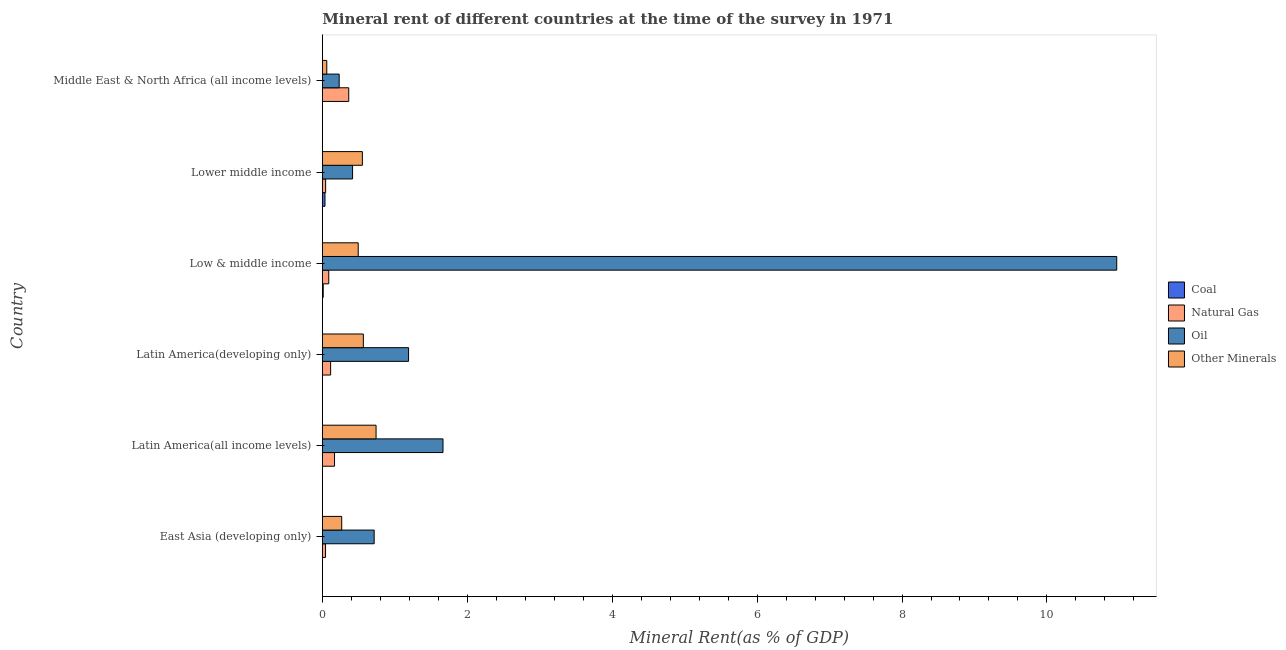How many different coloured bars are there?
Offer a very short reply. 4. How many groups of bars are there?
Provide a short and direct response. 6. Are the number of bars on each tick of the Y-axis equal?
Your answer should be very brief. Yes. How many bars are there on the 3rd tick from the top?
Your answer should be very brief. 4. What is the label of the 4th group of bars from the top?
Ensure brevity in your answer.  Latin America(developing only). What is the  rent of other minerals in Middle East & North Africa (all income levels)?
Your answer should be very brief. 0.06. Across all countries, what is the maximum coal rent?
Offer a terse response. 0.04. Across all countries, what is the minimum coal rent?
Your response must be concise. 2.424677920522231e-5. In which country was the coal rent maximum?
Keep it short and to the point. Lower middle income. In which country was the  rent of other minerals minimum?
Make the answer very short. Middle East & North Africa (all income levels). What is the total natural gas rent in the graph?
Make the answer very short. 0.83. What is the difference between the coal rent in Latin America(developing only) and that in Middle East & North Africa (all income levels)?
Provide a succinct answer. -0. What is the difference between the  rent of other minerals in Latin America(developing only) and the natural gas rent in Middle East & North Africa (all income levels)?
Your answer should be compact. 0.2. What is the average  rent of other minerals per country?
Keep it short and to the point. 0.45. What is the difference between the  rent of other minerals and coal rent in East Asia (developing only)?
Your response must be concise. 0.27. What is the ratio of the oil rent in Latin America(all income levels) to that in Middle East & North Africa (all income levels)?
Provide a succinct answer. 7.16. Is the difference between the oil rent in Latin America(all income levels) and Latin America(developing only) greater than the difference between the natural gas rent in Latin America(all income levels) and Latin America(developing only)?
Offer a very short reply. Yes. What is the difference between the highest and the second highest  rent of other minerals?
Keep it short and to the point. 0.17. What is the difference between the highest and the lowest natural gas rent?
Provide a short and direct response. 0.32. In how many countries, is the  rent of other minerals greater than the average  rent of other minerals taken over all countries?
Your response must be concise. 4. Is the sum of the  rent of other minerals in Latin America(developing only) and Middle East & North Africa (all income levels) greater than the maximum natural gas rent across all countries?
Your answer should be compact. Yes. What does the 1st bar from the top in Latin America(all income levels) represents?
Offer a terse response. Other Minerals. What does the 1st bar from the bottom in Latin America(developing only) represents?
Your response must be concise. Coal. How many bars are there?
Ensure brevity in your answer.  24. Are all the bars in the graph horizontal?
Your answer should be compact. Yes. How many countries are there in the graph?
Offer a very short reply. 6. What is the difference between two consecutive major ticks on the X-axis?
Provide a succinct answer. 2. How many legend labels are there?
Your response must be concise. 4. How are the legend labels stacked?
Your answer should be compact. Vertical. What is the title of the graph?
Provide a succinct answer. Mineral rent of different countries at the time of the survey in 1971. Does "Public sector management" appear as one of the legend labels in the graph?
Give a very brief answer. No. What is the label or title of the X-axis?
Make the answer very short. Mineral Rent(as % of GDP). What is the Mineral Rent(as % of GDP) of Coal in East Asia (developing only)?
Your answer should be compact. 0. What is the Mineral Rent(as % of GDP) in Natural Gas in East Asia (developing only)?
Your answer should be very brief. 0.04. What is the Mineral Rent(as % of GDP) in Oil in East Asia (developing only)?
Keep it short and to the point. 0.72. What is the Mineral Rent(as % of GDP) of Other Minerals in East Asia (developing only)?
Your answer should be very brief. 0.27. What is the Mineral Rent(as % of GDP) of Coal in Latin America(all income levels)?
Keep it short and to the point. 2.424677920522231e-5. What is the Mineral Rent(as % of GDP) of Natural Gas in Latin America(all income levels)?
Provide a succinct answer. 0.17. What is the Mineral Rent(as % of GDP) in Oil in Latin America(all income levels)?
Your response must be concise. 1.67. What is the Mineral Rent(as % of GDP) of Other Minerals in Latin America(all income levels)?
Your response must be concise. 0.74. What is the Mineral Rent(as % of GDP) in Coal in Latin America(developing only)?
Provide a succinct answer. 3.74111743887933e-5. What is the Mineral Rent(as % of GDP) of Natural Gas in Latin America(developing only)?
Make the answer very short. 0.11. What is the Mineral Rent(as % of GDP) of Oil in Latin America(developing only)?
Provide a short and direct response. 1.19. What is the Mineral Rent(as % of GDP) in Other Minerals in Latin America(developing only)?
Make the answer very short. 0.57. What is the Mineral Rent(as % of GDP) in Coal in Low & middle income?
Keep it short and to the point. 0.01. What is the Mineral Rent(as % of GDP) of Natural Gas in Low & middle income?
Keep it short and to the point. 0.09. What is the Mineral Rent(as % of GDP) in Oil in Low & middle income?
Provide a short and direct response. 10.96. What is the Mineral Rent(as % of GDP) in Other Minerals in Low & middle income?
Make the answer very short. 0.5. What is the Mineral Rent(as % of GDP) in Coal in Lower middle income?
Provide a succinct answer. 0.04. What is the Mineral Rent(as % of GDP) in Natural Gas in Lower middle income?
Your answer should be compact. 0.05. What is the Mineral Rent(as % of GDP) in Oil in Lower middle income?
Offer a terse response. 0.42. What is the Mineral Rent(as % of GDP) of Other Minerals in Lower middle income?
Make the answer very short. 0.55. What is the Mineral Rent(as % of GDP) in Coal in Middle East & North Africa (all income levels)?
Offer a very short reply. 0. What is the Mineral Rent(as % of GDP) of Natural Gas in Middle East & North Africa (all income levels)?
Provide a succinct answer. 0.36. What is the Mineral Rent(as % of GDP) in Oil in Middle East & North Africa (all income levels)?
Make the answer very short. 0.23. What is the Mineral Rent(as % of GDP) of Other Minerals in Middle East & North Africa (all income levels)?
Your answer should be very brief. 0.06. Across all countries, what is the maximum Mineral Rent(as % of GDP) in Coal?
Make the answer very short. 0.04. Across all countries, what is the maximum Mineral Rent(as % of GDP) in Natural Gas?
Your response must be concise. 0.36. Across all countries, what is the maximum Mineral Rent(as % of GDP) in Oil?
Provide a short and direct response. 10.96. Across all countries, what is the maximum Mineral Rent(as % of GDP) of Other Minerals?
Offer a very short reply. 0.74. Across all countries, what is the minimum Mineral Rent(as % of GDP) of Coal?
Ensure brevity in your answer.  2.424677920522231e-5. Across all countries, what is the minimum Mineral Rent(as % of GDP) of Natural Gas?
Make the answer very short. 0.04. Across all countries, what is the minimum Mineral Rent(as % of GDP) in Oil?
Your answer should be very brief. 0.23. Across all countries, what is the minimum Mineral Rent(as % of GDP) in Other Minerals?
Ensure brevity in your answer.  0.06. What is the total Mineral Rent(as % of GDP) in Coal in the graph?
Your answer should be very brief. 0.05. What is the total Mineral Rent(as % of GDP) of Natural Gas in the graph?
Make the answer very short. 0.83. What is the total Mineral Rent(as % of GDP) in Oil in the graph?
Ensure brevity in your answer.  15.18. What is the total Mineral Rent(as % of GDP) of Other Minerals in the graph?
Provide a succinct answer. 2.68. What is the difference between the Mineral Rent(as % of GDP) of Natural Gas in East Asia (developing only) and that in Latin America(all income levels)?
Offer a very short reply. -0.12. What is the difference between the Mineral Rent(as % of GDP) of Oil in East Asia (developing only) and that in Latin America(all income levels)?
Offer a terse response. -0.95. What is the difference between the Mineral Rent(as % of GDP) in Other Minerals in East Asia (developing only) and that in Latin America(all income levels)?
Your answer should be compact. -0.47. What is the difference between the Mineral Rent(as % of GDP) of Natural Gas in East Asia (developing only) and that in Latin America(developing only)?
Your answer should be very brief. -0.07. What is the difference between the Mineral Rent(as % of GDP) of Oil in East Asia (developing only) and that in Latin America(developing only)?
Make the answer very short. -0.47. What is the difference between the Mineral Rent(as % of GDP) of Other Minerals in East Asia (developing only) and that in Latin America(developing only)?
Make the answer very short. -0.3. What is the difference between the Mineral Rent(as % of GDP) of Coal in East Asia (developing only) and that in Low & middle income?
Your response must be concise. -0.01. What is the difference between the Mineral Rent(as % of GDP) of Natural Gas in East Asia (developing only) and that in Low & middle income?
Provide a short and direct response. -0.04. What is the difference between the Mineral Rent(as % of GDP) in Oil in East Asia (developing only) and that in Low & middle income?
Keep it short and to the point. -10.25. What is the difference between the Mineral Rent(as % of GDP) in Other Minerals in East Asia (developing only) and that in Low & middle income?
Offer a terse response. -0.23. What is the difference between the Mineral Rent(as % of GDP) of Coal in East Asia (developing only) and that in Lower middle income?
Your answer should be very brief. -0.04. What is the difference between the Mineral Rent(as % of GDP) of Natural Gas in East Asia (developing only) and that in Lower middle income?
Your response must be concise. -0. What is the difference between the Mineral Rent(as % of GDP) in Oil in East Asia (developing only) and that in Lower middle income?
Offer a terse response. 0.3. What is the difference between the Mineral Rent(as % of GDP) of Other Minerals in East Asia (developing only) and that in Lower middle income?
Your response must be concise. -0.28. What is the difference between the Mineral Rent(as % of GDP) of Coal in East Asia (developing only) and that in Middle East & North Africa (all income levels)?
Give a very brief answer. -0. What is the difference between the Mineral Rent(as % of GDP) in Natural Gas in East Asia (developing only) and that in Middle East & North Africa (all income levels)?
Provide a short and direct response. -0.32. What is the difference between the Mineral Rent(as % of GDP) of Oil in East Asia (developing only) and that in Middle East & North Africa (all income levels)?
Offer a very short reply. 0.48. What is the difference between the Mineral Rent(as % of GDP) of Other Minerals in East Asia (developing only) and that in Middle East & North Africa (all income levels)?
Ensure brevity in your answer.  0.21. What is the difference between the Mineral Rent(as % of GDP) of Coal in Latin America(all income levels) and that in Latin America(developing only)?
Keep it short and to the point. -0. What is the difference between the Mineral Rent(as % of GDP) in Natural Gas in Latin America(all income levels) and that in Latin America(developing only)?
Ensure brevity in your answer.  0.05. What is the difference between the Mineral Rent(as % of GDP) of Oil in Latin America(all income levels) and that in Latin America(developing only)?
Ensure brevity in your answer.  0.48. What is the difference between the Mineral Rent(as % of GDP) in Other Minerals in Latin America(all income levels) and that in Latin America(developing only)?
Provide a succinct answer. 0.18. What is the difference between the Mineral Rent(as % of GDP) in Coal in Latin America(all income levels) and that in Low & middle income?
Offer a very short reply. -0.01. What is the difference between the Mineral Rent(as % of GDP) in Oil in Latin America(all income levels) and that in Low & middle income?
Offer a very short reply. -9.3. What is the difference between the Mineral Rent(as % of GDP) in Other Minerals in Latin America(all income levels) and that in Low & middle income?
Ensure brevity in your answer.  0.25. What is the difference between the Mineral Rent(as % of GDP) in Coal in Latin America(all income levels) and that in Lower middle income?
Provide a short and direct response. -0.04. What is the difference between the Mineral Rent(as % of GDP) of Natural Gas in Latin America(all income levels) and that in Lower middle income?
Keep it short and to the point. 0.12. What is the difference between the Mineral Rent(as % of GDP) in Oil in Latin America(all income levels) and that in Lower middle income?
Your answer should be very brief. 1.25. What is the difference between the Mineral Rent(as % of GDP) in Other Minerals in Latin America(all income levels) and that in Lower middle income?
Give a very brief answer. 0.19. What is the difference between the Mineral Rent(as % of GDP) in Coal in Latin America(all income levels) and that in Middle East & North Africa (all income levels)?
Offer a terse response. -0. What is the difference between the Mineral Rent(as % of GDP) in Natural Gas in Latin America(all income levels) and that in Middle East & North Africa (all income levels)?
Offer a very short reply. -0.2. What is the difference between the Mineral Rent(as % of GDP) in Oil in Latin America(all income levels) and that in Middle East & North Africa (all income levels)?
Ensure brevity in your answer.  1.43. What is the difference between the Mineral Rent(as % of GDP) of Other Minerals in Latin America(all income levels) and that in Middle East & North Africa (all income levels)?
Provide a short and direct response. 0.68. What is the difference between the Mineral Rent(as % of GDP) of Coal in Latin America(developing only) and that in Low & middle income?
Your response must be concise. -0.01. What is the difference between the Mineral Rent(as % of GDP) of Natural Gas in Latin America(developing only) and that in Low & middle income?
Provide a short and direct response. 0.03. What is the difference between the Mineral Rent(as % of GDP) of Oil in Latin America(developing only) and that in Low & middle income?
Ensure brevity in your answer.  -9.77. What is the difference between the Mineral Rent(as % of GDP) of Other Minerals in Latin America(developing only) and that in Low & middle income?
Offer a terse response. 0.07. What is the difference between the Mineral Rent(as % of GDP) in Coal in Latin America(developing only) and that in Lower middle income?
Offer a very short reply. -0.04. What is the difference between the Mineral Rent(as % of GDP) of Natural Gas in Latin America(developing only) and that in Lower middle income?
Make the answer very short. 0.07. What is the difference between the Mineral Rent(as % of GDP) in Oil in Latin America(developing only) and that in Lower middle income?
Your answer should be compact. 0.77. What is the difference between the Mineral Rent(as % of GDP) of Other Minerals in Latin America(developing only) and that in Lower middle income?
Offer a terse response. 0.01. What is the difference between the Mineral Rent(as % of GDP) in Coal in Latin America(developing only) and that in Middle East & North Africa (all income levels)?
Your answer should be compact. -0. What is the difference between the Mineral Rent(as % of GDP) in Natural Gas in Latin America(developing only) and that in Middle East & North Africa (all income levels)?
Your answer should be very brief. -0.25. What is the difference between the Mineral Rent(as % of GDP) in Oil in Latin America(developing only) and that in Middle East & North Africa (all income levels)?
Your response must be concise. 0.96. What is the difference between the Mineral Rent(as % of GDP) in Other Minerals in Latin America(developing only) and that in Middle East & North Africa (all income levels)?
Offer a very short reply. 0.5. What is the difference between the Mineral Rent(as % of GDP) in Coal in Low & middle income and that in Lower middle income?
Your response must be concise. -0.02. What is the difference between the Mineral Rent(as % of GDP) of Natural Gas in Low & middle income and that in Lower middle income?
Make the answer very short. 0.04. What is the difference between the Mineral Rent(as % of GDP) of Oil in Low & middle income and that in Lower middle income?
Your answer should be compact. 10.55. What is the difference between the Mineral Rent(as % of GDP) of Other Minerals in Low & middle income and that in Lower middle income?
Ensure brevity in your answer.  -0.06. What is the difference between the Mineral Rent(as % of GDP) of Coal in Low & middle income and that in Middle East & North Africa (all income levels)?
Offer a terse response. 0.01. What is the difference between the Mineral Rent(as % of GDP) in Natural Gas in Low & middle income and that in Middle East & North Africa (all income levels)?
Make the answer very short. -0.28. What is the difference between the Mineral Rent(as % of GDP) of Oil in Low & middle income and that in Middle East & North Africa (all income levels)?
Make the answer very short. 10.73. What is the difference between the Mineral Rent(as % of GDP) of Other Minerals in Low & middle income and that in Middle East & North Africa (all income levels)?
Make the answer very short. 0.43. What is the difference between the Mineral Rent(as % of GDP) in Coal in Lower middle income and that in Middle East & North Africa (all income levels)?
Your answer should be very brief. 0.04. What is the difference between the Mineral Rent(as % of GDP) of Natural Gas in Lower middle income and that in Middle East & North Africa (all income levels)?
Make the answer very short. -0.32. What is the difference between the Mineral Rent(as % of GDP) in Oil in Lower middle income and that in Middle East & North Africa (all income levels)?
Keep it short and to the point. 0.18. What is the difference between the Mineral Rent(as % of GDP) of Other Minerals in Lower middle income and that in Middle East & North Africa (all income levels)?
Your answer should be compact. 0.49. What is the difference between the Mineral Rent(as % of GDP) in Coal in East Asia (developing only) and the Mineral Rent(as % of GDP) in Natural Gas in Latin America(all income levels)?
Your answer should be very brief. -0.17. What is the difference between the Mineral Rent(as % of GDP) of Coal in East Asia (developing only) and the Mineral Rent(as % of GDP) of Oil in Latin America(all income levels)?
Keep it short and to the point. -1.67. What is the difference between the Mineral Rent(as % of GDP) of Coal in East Asia (developing only) and the Mineral Rent(as % of GDP) of Other Minerals in Latin America(all income levels)?
Give a very brief answer. -0.74. What is the difference between the Mineral Rent(as % of GDP) of Natural Gas in East Asia (developing only) and the Mineral Rent(as % of GDP) of Oil in Latin America(all income levels)?
Your answer should be compact. -1.62. What is the difference between the Mineral Rent(as % of GDP) of Natural Gas in East Asia (developing only) and the Mineral Rent(as % of GDP) of Other Minerals in Latin America(all income levels)?
Make the answer very short. -0.7. What is the difference between the Mineral Rent(as % of GDP) of Oil in East Asia (developing only) and the Mineral Rent(as % of GDP) of Other Minerals in Latin America(all income levels)?
Your answer should be very brief. -0.03. What is the difference between the Mineral Rent(as % of GDP) in Coal in East Asia (developing only) and the Mineral Rent(as % of GDP) in Natural Gas in Latin America(developing only)?
Your response must be concise. -0.11. What is the difference between the Mineral Rent(as % of GDP) of Coal in East Asia (developing only) and the Mineral Rent(as % of GDP) of Oil in Latin America(developing only)?
Provide a short and direct response. -1.19. What is the difference between the Mineral Rent(as % of GDP) of Coal in East Asia (developing only) and the Mineral Rent(as % of GDP) of Other Minerals in Latin America(developing only)?
Keep it short and to the point. -0.57. What is the difference between the Mineral Rent(as % of GDP) of Natural Gas in East Asia (developing only) and the Mineral Rent(as % of GDP) of Oil in Latin America(developing only)?
Your answer should be very brief. -1.15. What is the difference between the Mineral Rent(as % of GDP) of Natural Gas in East Asia (developing only) and the Mineral Rent(as % of GDP) of Other Minerals in Latin America(developing only)?
Offer a very short reply. -0.52. What is the difference between the Mineral Rent(as % of GDP) in Oil in East Asia (developing only) and the Mineral Rent(as % of GDP) in Other Minerals in Latin America(developing only)?
Provide a short and direct response. 0.15. What is the difference between the Mineral Rent(as % of GDP) of Coal in East Asia (developing only) and the Mineral Rent(as % of GDP) of Natural Gas in Low & middle income?
Provide a succinct answer. -0.09. What is the difference between the Mineral Rent(as % of GDP) in Coal in East Asia (developing only) and the Mineral Rent(as % of GDP) in Oil in Low & middle income?
Ensure brevity in your answer.  -10.96. What is the difference between the Mineral Rent(as % of GDP) of Coal in East Asia (developing only) and the Mineral Rent(as % of GDP) of Other Minerals in Low & middle income?
Your answer should be compact. -0.5. What is the difference between the Mineral Rent(as % of GDP) in Natural Gas in East Asia (developing only) and the Mineral Rent(as % of GDP) in Oil in Low & middle income?
Make the answer very short. -10.92. What is the difference between the Mineral Rent(as % of GDP) in Natural Gas in East Asia (developing only) and the Mineral Rent(as % of GDP) in Other Minerals in Low & middle income?
Keep it short and to the point. -0.45. What is the difference between the Mineral Rent(as % of GDP) in Oil in East Asia (developing only) and the Mineral Rent(as % of GDP) in Other Minerals in Low & middle income?
Offer a very short reply. 0.22. What is the difference between the Mineral Rent(as % of GDP) of Coal in East Asia (developing only) and the Mineral Rent(as % of GDP) of Natural Gas in Lower middle income?
Your answer should be very brief. -0.05. What is the difference between the Mineral Rent(as % of GDP) in Coal in East Asia (developing only) and the Mineral Rent(as % of GDP) in Oil in Lower middle income?
Give a very brief answer. -0.42. What is the difference between the Mineral Rent(as % of GDP) of Coal in East Asia (developing only) and the Mineral Rent(as % of GDP) of Other Minerals in Lower middle income?
Your response must be concise. -0.55. What is the difference between the Mineral Rent(as % of GDP) in Natural Gas in East Asia (developing only) and the Mineral Rent(as % of GDP) in Oil in Lower middle income?
Offer a very short reply. -0.37. What is the difference between the Mineral Rent(as % of GDP) in Natural Gas in East Asia (developing only) and the Mineral Rent(as % of GDP) in Other Minerals in Lower middle income?
Ensure brevity in your answer.  -0.51. What is the difference between the Mineral Rent(as % of GDP) in Oil in East Asia (developing only) and the Mineral Rent(as % of GDP) in Other Minerals in Lower middle income?
Offer a terse response. 0.16. What is the difference between the Mineral Rent(as % of GDP) in Coal in East Asia (developing only) and the Mineral Rent(as % of GDP) in Natural Gas in Middle East & North Africa (all income levels)?
Your answer should be very brief. -0.36. What is the difference between the Mineral Rent(as % of GDP) of Coal in East Asia (developing only) and the Mineral Rent(as % of GDP) of Oil in Middle East & North Africa (all income levels)?
Provide a short and direct response. -0.23. What is the difference between the Mineral Rent(as % of GDP) in Coal in East Asia (developing only) and the Mineral Rent(as % of GDP) in Other Minerals in Middle East & North Africa (all income levels)?
Ensure brevity in your answer.  -0.06. What is the difference between the Mineral Rent(as % of GDP) of Natural Gas in East Asia (developing only) and the Mineral Rent(as % of GDP) of Oil in Middle East & North Africa (all income levels)?
Offer a very short reply. -0.19. What is the difference between the Mineral Rent(as % of GDP) in Natural Gas in East Asia (developing only) and the Mineral Rent(as % of GDP) in Other Minerals in Middle East & North Africa (all income levels)?
Make the answer very short. -0.02. What is the difference between the Mineral Rent(as % of GDP) in Oil in East Asia (developing only) and the Mineral Rent(as % of GDP) in Other Minerals in Middle East & North Africa (all income levels)?
Make the answer very short. 0.65. What is the difference between the Mineral Rent(as % of GDP) in Coal in Latin America(all income levels) and the Mineral Rent(as % of GDP) in Natural Gas in Latin America(developing only)?
Your response must be concise. -0.11. What is the difference between the Mineral Rent(as % of GDP) of Coal in Latin America(all income levels) and the Mineral Rent(as % of GDP) of Oil in Latin America(developing only)?
Your response must be concise. -1.19. What is the difference between the Mineral Rent(as % of GDP) of Coal in Latin America(all income levels) and the Mineral Rent(as % of GDP) of Other Minerals in Latin America(developing only)?
Provide a succinct answer. -0.57. What is the difference between the Mineral Rent(as % of GDP) in Natural Gas in Latin America(all income levels) and the Mineral Rent(as % of GDP) in Oil in Latin America(developing only)?
Offer a terse response. -1.02. What is the difference between the Mineral Rent(as % of GDP) of Natural Gas in Latin America(all income levels) and the Mineral Rent(as % of GDP) of Other Minerals in Latin America(developing only)?
Give a very brief answer. -0.4. What is the difference between the Mineral Rent(as % of GDP) of Oil in Latin America(all income levels) and the Mineral Rent(as % of GDP) of Other Minerals in Latin America(developing only)?
Provide a succinct answer. 1.1. What is the difference between the Mineral Rent(as % of GDP) in Coal in Latin America(all income levels) and the Mineral Rent(as % of GDP) in Natural Gas in Low & middle income?
Keep it short and to the point. -0.09. What is the difference between the Mineral Rent(as % of GDP) in Coal in Latin America(all income levels) and the Mineral Rent(as % of GDP) in Oil in Low & middle income?
Keep it short and to the point. -10.96. What is the difference between the Mineral Rent(as % of GDP) in Coal in Latin America(all income levels) and the Mineral Rent(as % of GDP) in Other Minerals in Low & middle income?
Provide a succinct answer. -0.5. What is the difference between the Mineral Rent(as % of GDP) in Natural Gas in Latin America(all income levels) and the Mineral Rent(as % of GDP) in Oil in Low & middle income?
Your answer should be very brief. -10.79. What is the difference between the Mineral Rent(as % of GDP) in Natural Gas in Latin America(all income levels) and the Mineral Rent(as % of GDP) in Other Minerals in Low & middle income?
Your response must be concise. -0.33. What is the difference between the Mineral Rent(as % of GDP) of Oil in Latin America(all income levels) and the Mineral Rent(as % of GDP) of Other Minerals in Low & middle income?
Provide a short and direct response. 1.17. What is the difference between the Mineral Rent(as % of GDP) in Coal in Latin America(all income levels) and the Mineral Rent(as % of GDP) in Natural Gas in Lower middle income?
Offer a very short reply. -0.05. What is the difference between the Mineral Rent(as % of GDP) in Coal in Latin America(all income levels) and the Mineral Rent(as % of GDP) in Oil in Lower middle income?
Provide a short and direct response. -0.42. What is the difference between the Mineral Rent(as % of GDP) of Coal in Latin America(all income levels) and the Mineral Rent(as % of GDP) of Other Minerals in Lower middle income?
Your answer should be compact. -0.55. What is the difference between the Mineral Rent(as % of GDP) in Natural Gas in Latin America(all income levels) and the Mineral Rent(as % of GDP) in Oil in Lower middle income?
Offer a terse response. -0.25. What is the difference between the Mineral Rent(as % of GDP) in Natural Gas in Latin America(all income levels) and the Mineral Rent(as % of GDP) in Other Minerals in Lower middle income?
Give a very brief answer. -0.38. What is the difference between the Mineral Rent(as % of GDP) in Oil in Latin America(all income levels) and the Mineral Rent(as % of GDP) in Other Minerals in Lower middle income?
Offer a terse response. 1.11. What is the difference between the Mineral Rent(as % of GDP) in Coal in Latin America(all income levels) and the Mineral Rent(as % of GDP) in Natural Gas in Middle East & North Africa (all income levels)?
Make the answer very short. -0.36. What is the difference between the Mineral Rent(as % of GDP) of Coal in Latin America(all income levels) and the Mineral Rent(as % of GDP) of Oil in Middle East & North Africa (all income levels)?
Your response must be concise. -0.23. What is the difference between the Mineral Rent(as % of GDP) of Coal in Latin America(all income levels) and the Mineral Rent(as % of GDP) of Other Minerals in Middle East & North Africa (all income levels)?
Your response must be concise. -0.06. What is the difference between the Mineral Rent(as % of GDP) of Natural Gas in Latin America(all income levels) and the Mineral Rent(as % of GDP) of Oil in Middle East & North Africa (all income levels)?
Keep it short and to the point. -0.06. What is the difference between the Mineral Rent(as % of GDP) in Natural Gas in Latin America(all income levels) and the Mineral Rent(as % of GDP) in Other Minerals in Middle East & North Africa (all income levels)?
Offer a terse response. 0.11. What is the difference between the Mineral Rent(as % of GDP) of Oil in Latin America(all income levels) and the Mineral Rent(as % of GDP) of Other Minerals in Middle East & North Africa (all income levels)?
Provide a short and direct response. 1.6. What is the difference between the Mineral Rent(as % of GDP) of Coal in Latin America(developing only) and the Mineral Rent(as % of GDP) of Natural Gas in Low & middle income?
Ensure brevity in your answer.  -0.09. What is the difference between the Mineral Rent(as % of GDP) in Coal in Latin America(developing only) and the Mineral Rent(as % of GDP) in Oil in Low & middle income?
Keep it short and to the point. -10.96. What is the difference between the Mineral Rent(as % of GDP) of Coal in Latin America(developing only) and the Mineral Rent(as % of GDP) of Other Minerals in Low & middle income?
Ensure brevity in your answer.  -0.5. What is the difference between the Mineral Rent(as % of GDP) in Natural Gas in Latin America(developing only) and the Mineral Rent(as % of GDP) in Oil in Low & middle income?
Keep it short and to the point. -10.85. What is the difference between the Mineral Rent(as % of GDP) of Natural Gas in Latin America(developing only) and the Mineral Rent(as % of GDP) of Other Minerals in Low & middle income?
Ensure brevity in your answer.  -0.38. What is the difference between the Mineral Rent(as % of GDP) of Oil in Latin America(developing only) and the Mineral Rent(as % of GDP) of Other Minerals in Low & middle income?
Your answer should be compact. 0.69. What is the difference between the Mineral Rent(as % of GDP) of Coal in Latin America(developing only) and the Mineral Rent(as % of GDP) of Natural Gas in Lower middle income?
Make the answer very short. -0.05. What is the difference between the Mineral Rent(as % of GDP) in Coal in Latin America(developing only) and the Mineral Rent(as % of GDP) in Oil in Lower middle income?
Offer a very short reply. -0.42. What is the difference between the Mineral Rent(as % of GDP) in Coal in Latin America(developing only) and the Mineral Rent(as % of GDP) in Other Minerals in Lower middle income?
Provide a short and direct response. -0.55. What is the difference between the Mineral Rent(as % of GDP) of Natural Gas in Latin America(developing only) and the Mineral Rent(as % of GDP) of Oil in Lower middle income?
Your answer should be very brief. -0.3. What is the difference between the Mineral Rent(as % of GDP) in Natural Gas in Latin America(developing only) and the Mineral Rent(as % of GDP) in Other Minerals in Lower middle income?
Give a very brief answer. -0.44. What is the difference between the Mineral Rent(as % of GDP) of Oil in Latin America(developing only) and the Mineral Rent(as % of GDP) of Other Minerals in Lower middle income?
Give a very brief answer. 0.64. What is the difference between the Mineral Rent(as % of GDP) in Coal in Latin America(developing only) and the Mineral Rent(as % of GDP) in Natural Gas in Middle East & North Africa (all income levels)?
Make the answer very short. -0.36. What is the difference between the Mineral Rent(as % of GDP) of Coal in Latin America(developing only) and the Mineral Rent(as % of GDP) of Oil in Middle East & North Africa (all income levels)?
Offer a terse response. -0.23. What is the difference between the Mineral Rent(as % of GDP) in Coal in Latin America(developing only) and the Mineral Rent(as % of GDP) in Other Minerals in Middle East & North Africa (all income levels)?
Offer a terse response. -0.06. What is the difference between the Mineral Rent(as % of GDP) in Natural Gas in Latin America(developing only) and the Mineral Rent(as % of GDP) in Oil in Middle East & North Africa (all income levels)?
Ensure brevity in your answer.  -0.12. What is the difference between the Mineral Rent(as % of GDP) of Natural Gas in Latin America(developing only) and the Mineral Rent(as % of GDP) of Other Minerals in Middle East & North Africa (all income levels)?
Give a very brief answer. 0.05. What is the difference between the Mineral Rent(as % of GDP) in Oil in Latin America(developing only) and the Mineral Rent(as % of GDP) in Other Minerals in Middle East & North Africa (all income levels)?
Offer a very short reply. 1.13. What is the difference between the Mineral Rent(as % of GDP) of Coal in Low & middle income and the Mineral Rent(as % of GDP) of Natural Gas in Lower middle income?
Your response must be concise. -0.03. What is the difference between the Mineral Rent(as % of GDP) in Coal in Low & middle income and the Mineral Rent(as % of GDP) in Oil in Lower middle income?
Provide a short and direct response. -0.41. What is the difference between the Mineral Rent(as % of GDP) in Coal in Low & middle income and the Mineral Rent(as % of GDP) in Other Minerals in Lower middle income?
Your answer should be compact. -0.54. What is the difference between the Mineral Rent(as % of GDP) in Natural Gas in Low & middle income and the Mineral Rent(as % of GDP) in Oil in Lower middle income?
Keep it short and to the point. -0.33. What is the difference between the Mineral Rent(as % of GDP) in Natural Gas in Low & middle income and the Mineral Rent(as % of GDP) in Other Minerals in Lower middle income?
Provide a succinct answer. -0.46. What is the difference between the Mineral Rent(as % of GDP) in Oil in Low & middle income and the Mineral Rent(as % of GDP) in Other Minerals in Lower middle income?
Offer a very short reply. 10.41. What is the difference between the Mineral Rent(as % of GDP) of Coal in Low & middle income and the Mineral Rent(as % of GDP) of Natural Gas in Middle East & North Africa (all income levels)?
Give a very brief answer. -0.35. What is the difference between the Mineral Rent(as % of GDP) of Coal in Low & middle income and the Mineral Rent(as % of GDP) of Oil in Middle East & North Africa (all income levels)?
Your answer should be very brief. -0.22. What is the difference between the Mineral Rent(as % of GDP) of Coal in Low & middle income and the Mineral Rent(as % of GDP) of Other Minerals in Middle East & North Africa (all income levels)?
Your answer should be compact. -0.05. What is the difference between the Mineral Rent(as % of GDP) in Natural Gas in Low & middle income and the Mineral Rent(as % of GDP) in Oil in Middle East & North Africa (all income levels)?
Offer a very short reply. -0.14. What is the difference between the Mineral Rent(as % of GDP) of Natural Gas in Low & middle income and the Mineral Rent(as % of GDP) of Other Minerals in Middle East & North Africa (all income levels)?
Your answer should be very brief. 0.03. What is the difference between the Mineral Rent(as % of GDP) in Oil in Low & middle income and the Mineral Rent(as % of GDP) in Other Minerals in Middle East & North Africa (all income levels)?
Your answer should be compact. 10.9. What is the difference between the Mineral Rent(as % of GDP) of Coal in Lower middle income and the Mineral Rent(as % of GDP) of Natural Gas in Middle East & North Africa (all income levels)?
Your answer should be very brief. -0.33. What is the difference between the Mineral Rent(as % of GDP) in Coal in Lower middle income and the Mineral Rent(as % of GDP) in Oil in Middle East & North Africa (all income levels)?
Provide a succinct answer. -0.2. What is the difference between the Mineral Rent(as % of GDP) in Coal in Lower middle income and the Mineral Rent(as % of GDP) in Other Minerals in Middle East & North Africa (all income levels)?
Your answer should be very brief. -0.02. What is the difference between the Mineral Rent(as % of GDP) of Natural Gas in Lower middle income and the Mineral Rent(as % of GDP) of Oil in Middle East & North Africa (all income levels)?
Provide a short and direct response. -0.19. What is the difference between the Mineral Rent(as % of GDP) of Natural Gas in Lower middle income and the Mineral Rent(as % of GDP) of Other Minerals in Middle East & North Africa (all income levels)?
Give a very brief answer. -0.02. What is the difference between the Mineral Rent(as % of GDP) in Oil in Lower middle income and the Mineral Rent(as % of GDP) in Other Minerals in Middle East & North Africa (all income levels)?
Your answer should be compact. 0.36. What is the average Mineral Rent(as % of GDP) in Coal per country?
Give a very brief answer. 0.01. What is the average Mineral Rent(as % of GDP) of Natural Gas per country?
Make the answer very short. 0.14. What is the average Mineral Rent(as % of GDP) in Oil per country?
Provide a succinct answer. 2.53. What is the average Mineral Rent(as % of GDP) in Other Minerals per country?
Give a very brief answer. 0.45. What is the difference between the Mineral Rent(as % of GDP) in Coal and Mineral Rent(as % of GDP) in Natural Gas in East Asia (developing only)?
Offer a terse response. -0.04. What is the difference between the Mineral Rent(as % of GDP) of Coal and Mineral Rent(as % of GDP) of Oil in East Asia (developing only)?
Your answer should be compact. -0.72. What is the difference between the Mineral Rent(as % of GDP) of Coal and Mineral Rent(as % of GDP) of Other Minerals in East Asia (developing only)?
Provide a short and direct response. -0.27. What is the difference between the Mineral Rent(as % of GDP) in Natural Gas and Mineral Rent(as % of GDP) in Oil in East Asia (developing only)?
Make the answer very short. -0.67. What is the difference between the Mineral Rent(as % of GDP) of Natural Gas and Mineral Rent(as % of GDP) of Other Minerals in East Asia (developing only)?
Offer a terse response. -0.22. What is the difference between the Mineral Rent(as % of GDP) of Oil and Mineral Rent(as % of GDP) of Other Minerals in East Asia (developing only)?
Provide a short and direct response. 0.45. What is the difference between the Mineral Rent(as % of GDP) in Coal and Mineral Rent(as % of GDP) in Natural Gas in Latin America(all income levels)?
Provide a short and direct response. -0.17. What is the difference between the Mineral Rent(as % of GDP) in Coal and Mineral Rent(as % of GDP) in Oil in Latin America(all income levels)?
Offer a terse response. -1.67. What is the difference between the Mineral Rent(as % of GDP) in Coal and Mineral Rent(as % of GDP) in Other Minerals in Latin America(all income levels)?
Your answer should be compact. -0.74. What is the difference between the Mineral Rent(as % of GDP) of Natural Gas and Mineral Rent(as % of GDP) of Oil in Latin America(all income levels)?
Offer a terse response. -1.5. What is the difference between the Mineral Rent(as % of GDP) of Natural Gas and Mineral Rent(as % of GDP) of Other Minerals in Latin America(all income levels)?
Give a very brief answer. -0.57. What is the difference between the Mineral Rent(as % of GDP) of Oil and Mineral Rent(as % of GDP) of Other Minerals in Latin America(all income levels)?
Offer a terse response. 0.92. What is the difference between the Mineral Rent(as % of GDP) in Coal and Mineral Rent(as % of GDP) in Natural Gas in Latin America(developing only)?
Ensure brevity in your answer.  -0.11. What is the difference between the Mineral Rent(as % of GDP) in Coal and Mineral Rent(as % of GDP) in Oil in Latin America(developing only)?
Ensure brevity in your answer.  -1.19. What is the difference between the Mineral Rent(as % of GDP) in Coal and Mineral Rent(as % of GDP) in Other Minerals in Latin America(developing only)?
Make the answer very short. -0.57. What is the difference between the Mineral Rent(as % of GDP) in Natural Gas and Mineral Rent(as % of GDP) in Oil in Latin America(developing only)?
Make the answer very short. -1.08. What is the difference between the Mineral Rent(as % of GDP) of Natural Gas and Mineral Rent(as % of GDP) of Other Minerals in Latin America(developing only)?
Make the answer very short. -0.45. What is the difference between the Mineral Rent(as % of GDP) in Oil and Mineral Rent(as % of GDP) in Other Minerals in Latin America(developing only)?
Make the answer very short. 0.62. What is the difference between the Mineral Rent(as % of GDP) in Coal and Mineral Rent(as % of GDP) in Natural Gas in Low & middle income?
Your answer should be very brief. -0.08. What is the difference between the Mineral Rent(as % of GDP) in Coal and Mineral Rent(as % of GDP) in Oil in Low & middle income?
Keep it short and to the point. -10.95. What is the difference between the Mineral Rent(as % of GDP) of Coal and Mineral Rent(as % of GDP) of Other Minerals in Low & middle income?
Provide a short and direct response. -0.48. What is the difference between the Mineral Rent(as % of GDP) of Natural Gas and Mineral Rent(as % of GDP) of Oil in Low & middle income?
Offer a very short reply. -10.87. What is the difference between the Mineral Rent(as % of GDP) of Natural Gas and Mineral Rent(as % of GDP) of Other Minerals in Low & middle income?
Give a very brief answer. -0.41. What is the difference between the Mineral Rent(as % of GDP) in Oil and Mineral Rent(as % of GDP) in Other Minerals in Low & middle income?
Provide a short and direct response. 10.47. What is the difference between the Mineral Rent(as % of GDP) of Coal and Mineral Rent(as % of GDP) of Natural Gas in Lower middle income?
Make the answer very short. -0.01. What is the difference between the Mineral Rent(as % of GDP) of Coal and Mineral Rent(as % of GDP) of Oil in Lower middle income?
Make the answer very short. -0.38. What is the difference between the Mineral Rent(as % of GDP) in Coal and Mineral Rent(as % of GDP) in Other Minerals in Lower middle income?
Make the answer very short. -0.52. What is the difference between the Mineral Rent(as % of GDP) of Natural Gas and Mineral Rent(as % of GDP) of Oil in Lower middle income?
Your response must be concise. -0.37. What is the difference between the Mineral Rent(as % of GDP) in Natural Gas and Mineral Rent(as % of GDP) in Other Minerals in Lower middle income?
Your answer should be very brief. -0.51. What is the difference between the Mineral Rent(as % of GDP) of Oil and Mineral Rent(as % of GDP) of Other Minerals in Lower middle income?
Offer a very short reply. -0.14. What is the difference between the Mineral Rent(as % of GDP) in Coal and Mineral Rent(as % of GDP) in Natural Gas in Middle East & North Africa (all income levels)?
Ensure brevity in your answer.  -0.36. What is the difference between the Mineral Rent(as % of GDP) of Coal and Mineral Rent(as % of GDP) of Oil in Middle East & North Africa (all income levels)?
Your answer should be compact. -0.23. What is the difference between the Mineral Rent(as % of GDP) of Coal and Mineral Rent(as % of GDP) of Other Minerals in Middle East & North Africa (all income levels)?
Keep it short and to the point. -0.06. What is the difference between the Mineral Rent(as % of GDP) in Natural Gas and Mineral Rent(as % of GDP) in Oil in Middle East & North Africa (all income levels)?
Provide a short and direct response. 0.13. What is the difference between the Mineral Rent(as % of GDP) in Natural Gas and Mineral Rent(as % of GDP) in Other Minerals in Middle East & North Africa (all income levels)?
Offer a terse response. 0.3. What is the difference between the Mineral Rent(as % of GDP) in Oil and Mineral Rent(as % of GDP) in Other Minerals in Middle East & North Africa (all income levels)?
Offer a terse response. 0.17. What is the ratio of the Mineral Rent(as % of GDP) in Coal in East Asia (developing only) to that in Latin America(all income levels)?
Your answer should be compact. 7.73. What is the ratio of the Mineral Rent(as % of GDP) in Natural Gas in East Asia (developing only) to that in Latin America(all income levels)?
Provide a short and direct response. 0.26. What is the ratio of the Mineral Rent(as % of GDP) in Oil in East Asia (developing only) to that in Latin America(all income levels)?
Make the answer very short. 0.43. What is the ratio of the Mineral Rent(as % of GDP) of Other Minerals in East Asia (developing only) to that in Latin America(all income levels)?
Make the answer very short. 0.36. What is the ratio of the Mineral Rent(as % of GDP) of Coal in East Asia (developing only) to that in Latin America(developing only)?
Provide a short and direct response. 5.01. What is the ratio of the Mineral Rent(as % of GDP) of Natural Gas in East Asia (developing only) to that in Latin America(developing only)?
Your response must be concise. 0.39. What is the ratio of the Mineral Rent(as % of GDP) in Oil in East Asia (developing only) to that in Latin America(developing only)?
Provide a short and direct response. 0.6. What is the ratio of the Mineral Rent(as % of GDP) in Other Minerals in East Asia (developing only) to that in Latin America(developing only)?
Make the answer very short. 0.47. What is the ratio of the Mineral Rent(as % of GDP) in Coal in East Asia (developing only) to that in Low & middle income?
Your response must be concise. 0.02. What is the ratio of the Mineral Rent(as % of GDP) in Natural Gas in East Asia (developing only) to that in Low & middle income?
Keep it short and to the point. 0.5. What is the ratio of the Mineral Rent(as % of GDP) in Oil in East Asia (developing only) to that in Low & middle income?
Provide a short and direct response. 0.07. What is the ratio of the Mineral Rent(as % of GDP) in Other Minerals in East Asia (developing only) to that in Low & middle income?
Offer a terse response. 0.54. What is the ratio of the Mineral Rent(as % of GDP) of Coal in East Asia (developing only) to that in Lower middle income?
Provide a succinct answer. 0.01. What is the ratio of the Mineral Rent(as % of GDP) of Natural Gas in East Asia (developing only) to that in Lower middle income?
Keep it short and to the point. 0.97. What is the ratio of the Mineral Rent(as % of GDP) of Oil in East Asia (developing only) to that in Lower middle income?
Offer a very short reply. 1.71. What is the ratio of the Mineral Rent(as % of GDP) in Other Minerals in East Asia (developing only) to that in Lower middle income?
Your answer should be very brief. 0.48. What is the ratio of the Mineral Rent(as % of GDP) in Coal in East Asia (developing only) to that in Middle East & North Africa (all income levels)?
Provide a succinct answer. 0.29. What is the ratio of the Mineral Rent(as % of GDP) of Natural Gas in East Asia (developing only) to that in Middle East & North Africa (all income levels)?
Give a very brief answer. 0.12. What is the ratio of the Mineral Rent(as % of GDP) of Oil in East Asia (developing only) to that in Middle East & North Africa (all income levels)?
Keep it short and to the point. 3.08. What is the ratio of the Mineral Rent(as % of GDP) of Other Minerals in East Asia (developing only) to that in Middle East & North Africa (all income levels)?
Give a very brief answer. 4.35. What is the ratio of the Mineral Rent(as % of GDP) in Coal in Latin America(all income levels) to that in Latin America(developing only)?
Offer a very short reply. 0.65. What is the ratio of the Mineral Rent(as % of GDP) of Natural Gas in Latin America(all income levels) to that in Latin America(developing only)?
Your response must be concise. 1.47. What is the ratio of the Mineral Rent(as % of GDP) in Oil in Latin America(all income levels) to that in Latin America(developing only)?
Your answer should be compact. 1.4. What is the ratio of the Mineral Rent(as % of GDP) in Other Minerals in Latin America(all income levels) to that in Latin America(developing only)?
Give a very brief answer. 1.31. What is the ratio of the Mineral Rent(as % of GDP) of Coal in Latin America(all income levels) to that in Low & middle income?
Offer a very short reply. 0. What is the ratio of the Mineral Rent(as % of GDP) of Natural Gas in Latin America(all income levels) to that in Low & middle income?
Offer a very short reply. 1.9. What is the ratio of the Mineral Rent(as % of GDP) in Oil in Latin America(all income levels) to that in Low & middle income?
Give a very brief answer. 0.15. What is the ratio of the Mineral Rent(as % of GDP) in Other Minerals in Latin America(all income levels) to that in Low & middle income?
Offer a terse response. 1.5. What is the ratio of the Mineral Rent(as % of GDP) in Coal in Latin America(all income levels) to that in Lower middle income?
Your answer should be very brief. 0. What is the ratio of the Mineral Rent(as % of GDP) in Natural Gas in Latin America(all income levels) to that in Lower middle income?
Provide a short and direct response. 3.68. What is the ratio of the Mineral Rent(as % of GDP) in Oil in Latin America(all income levels) to that in Lower middle income?
Provide a short and direct response. 3.99. What is the ratio of the Mineral Rent(as % of GDP) in Other Minerals in Latin America(all income levels) to that in Lower middle income?
Your response must be concise. 1.34. What is the ratio of the Mineral Rent(as % of GDP) in Coal in Latin America(all income levels) to that in Middle East & North Africa (all income levels)?
Provide a short and direct response. 0.04. What is the ratio of the Mineral Rent(as % of GDP) of Natural Gas in Latin America(all income levels) to that in Middle East & North Africa (all income levels)?
Offer a very short reply. 0.46. What is the ratio of the Mineral Rent(as % of GDP) in Oil in Latin America(all income levels) to that in Middle East & North Africa (all income levels)?
Keep it short and to the point. 7.16. What is the ratio of the Mineral Rent(as % of GDP) of Other Minerals in Latin America(all income levels) to that in Middle East & North Africa (all income levels)?
Your answer should be very brief. 12.05. What is the ratio of the Mineral Rent(as % of GDP) in Coal in Latin America(developing only) to that in Low & middle income?
Your answer should be compact. 0. What is the ratio of the Mineral Rent(as % of GDP) in Natural Gas in Latin America(developing only) to that in Low & middle income?
Your response must be concise. 1.29. What is the ratio of the Mineral Rent(as % of GDP) in Oil in Latin America(developing only) to that in Low & middle income?
Offer a very short reply. 0.11. What is the ratio of the Mineral Rent(as % of GDP) of Other Minerals in Latin America(developing only) to that in Low & middle income?
Give a very brief answer. 1.14. What is the ratio of the Mineral Rent(as % of GDP) in Coal in Latin America(developing only) to that in Lower middle income?
Give a very brief answer. 0. What is the ratio of the Mineral Rent(as % of GDP) of Natural Gas in Latin America(developing only) to that in Lower middle income?
Provide a short and direct response. 2.5. What is the ratio of the Mineral Rent(as % of GDP) of Oil in Latin America(developing only) to that in Lower middle income?
Provide a succinct answer. 2.85. What is the ratio of the Mineral Rent(as % of GDP) of Other Minerals in Latin America(developing only) to that in Lower middle income?
Your response must be concise. 1.02. What is the ratio of the Mineral Rent(as % of GDP) of Coal in Latin America(developing only) to that in Middle East & North Africa (all income levels)?
Offer a terse response. 0.06. What is the ratio of the Mineral Rent(as % of GDP) in Natural Gas in Latin America(developing only) to that in Middle East & North Africa (all income levels)?
Offer a very short reply. 0.31. What is the ratio of the Mineral Rent(as % of GDP) in Oil in Latin America(developing only) to that in Middle East & North Africa (all income levels)?
Your response must be concise. 5.12. What is the ratio of the Mineral Rent(as % of GDP) in Other Minerals in Latin America(developing only) to that in Middle East & North Africa (all income levels)?
Ensure brevity in your answer.  9.2. What is the ratio of the Mineral Rent(as % of GDP) of Coal in Low & middle income to that in Lower middle income?
Offer a terse response. 0.33. What is the ratio of the Mineral Rent(as % of GDP) in Natural Gas in Low & middle income to that in Lower middle income?
Your response must be concise. 1.93. What is the ratio of the Mineral Rent(as % of GDP) of Oil in Low & middle income to that in Lower middle income?
Provide a short and direct response. 26.26. What is the ratio of the Mineral Rent(as % of GDP) of Other Minerals in Low & middle income to that in Lower middle income?
Your answer should be very brief. 0.9. What is the ratio of the Mineral Rent(as % of GDP) of Coal in Low & middle income to that in Middle East & North Africa (all income levels)?
Provide a succinct answer. 18.77. What is the ratio of the Mineral Rent(as % of GDP) of Natural Gas in Low & middle income to that in Middle East & North Africa (all income levels)?
Provide a succinct answer. 0.24. What is the ratio of the Mineral Rent(as % of GDP) of Oil in Low & middle income to that in Middle East & North Africa (all income levels)?
Keep it short and to the point. 47.15. What is the ratio of the Mineral Rent(as % of GDP) of Other Minerals in Low & middle income to that in Middle East & North Africa (all income levels)?
Provide a short and direct response. 8.05. What is the ratio of the Mineral Rent(as % of GDP) in Coal in Lower middle income to that in Middle East & North Africa (all income levels)?
Ensure brevity in your answer.  56.65. What is the ratio of the Mineral Rent(as % of GDP) of Natural Gas in Lower middle income to that in Middle East & North Africa (all income levels)?
Your answer should be very brief. 0.13. What is the ratio of the Mineral Rent(as % of GDP) of Oil in Lower middle income to that in Middle East & North Africa (all income levels)?
Make the answer very short. 1.8. What is the ratio of the Mineral Rent(as % of GDP) of Other Minerals in Lower middle income to that in Middle East & North Africa (all income levels)?
Provide a short and direct response. 8.98. What is the difference between the highest and the second highest Mineral Rent(as % of GDP) in Coal?
Ensure brevity in your answer.  0.02. What is the difference between the highest and the second highest Mineral Rent(as % of GDP) in Natural Gas?
Offer a terse response. 0.2. What is the difference between the highest and the second highest Mineral Rent(as % of GDP) of Oil?
Provide a short and direct response. 9.3. What is the difference between the highest and the second highest Mineral Rent(as % of GDP) in Other Minerals?
Keep it short and to the point. 0.18. What is the difference between the highest and the lowest Mineral Rent(as % of GDP) of Coal?
Your answer should be compact. 0.04. What is the difference between the highest and the lowest Mineral Rent(as % of GDP) of Natural Gas?
Offer a terse response. 0.32. What is the difference between the highest and the lowest Mineral Rent(as % of GDP) in Oil?
Offer a very short reply. 10.73. What is the difference between the highest and the lowest Mineral Rent(as % of GDP) of Other Minerals?
Give a very brief answer. 0.68. 